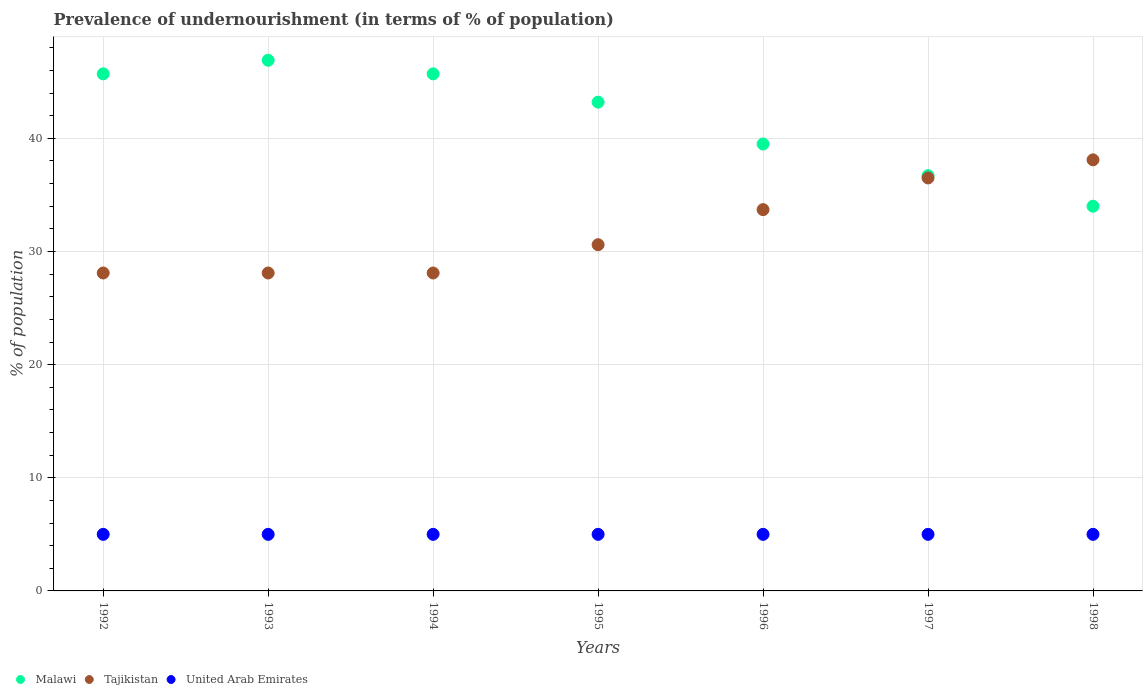How many different coloured dotlines are there?
Your answer should be very brief. 3. What is the percentage of undernourished population in United Arab Emirates in 1998?
Make the answer very short. 5. Across all years, what is the maximum percentage of undernourished population in Malawi?
Provide a short and direct response. 46.9. Across all years, what is the minimum percentage of undernourished population in Tajikistan?
Your response must be concise. 28.1. In which year was the percentage of undernourished population in United Arab Emirates minimum?
Your response must be concise. 1992. What is the total percentage of undernourished population in Malawi in the graph?
Provide a short and direct response. 291.7. What is the difference between the percentage of undernourished population in United Arab Emirates in 1993 and that in 1994?
Give a very brief answer. 0. What is the difference between the percentage of undernourished population in Tajikistan in 1998 and the percentage of undernourished population in United Arab Emirates in 1996?
Keep it short and to the point. 33.1. In the year 1996, what is the difference between the percentage of undernourished population in Malawi and percentage of undernourished population in Tajikistan?
Your answer should be compact. 5.8. What is the ratio of the percentage of undernourished population in Tajikistan in 1992 to that in 1997?
Ensure brevity in your answer.  0.77. Is the percentage of undernourished population in Tajikistan in 1994 less than that in 1996?
Keep it short and to the point. Yes. What is the difference between the highest and the second highest percentage of undernourished population in Malawi?
Your answer should be very brief. 1.2. What is the difference between the highest and the lowest percentage of undernourished population in Malawi?
Provide a succinct answer. 12.9. Is the percentage of undernourished population in United Arab Emirates strictly less than the percentage of undernourished population in Malawi over the years?
Provide a succinct answer. Yes. How many dotlines are there?
Your answer should be compact. 3. What is the title of the graph?
Give a very brief answer. Prevalence of undernourishment (in terms of % of population). What is the label or title of the X-axis?
Offer a terse response. Years. What is the label or title of the Y-axis?
Your answer should be very brief. % of population. What is the % of population in Malawi in 1992?
Your answer should be compact. 45.7. What is the % of population in Tajikistan in 1992?
Your answer should be compact. 28.1. What is the % of population in United Arab Emirates in 1992?
Ensure brevity in your answer.  5. What is the % of population in Malawi in 1993?
Your response must be concise. 46.9. What is the % of population in Tajikistan in 1993?
Offer a very short reply. 28.1. What is the % of population of Malawi in 1994?
Ensure brevity in your answer.  45.7. What is the % of population in Tajikistan in 1994?
Make the answer very short. 28.1. What is the % of population in Malawi in 1995?
Provide a succinct answer. 43.2. What is the % of population of Tajikistan in 1995?
Provide a short and direct response. 30.6. What is the % of population in Malawi in 1996?
Make the answer very short. 39.5. What is the % of population of Tajikistan in 1996?
Provide a succinct answer. 33.7. What is the % of population in United Arab Emirates in 1996?
Your answer should be very brief. 5. What is the % of population of Malawi in 1997?
Make the answer very short. 36.7. What is the % of population in Tajikistan in 1997?
Give a very brief answer. 36.5. What is the % of population in Malawi in 1998?
Keep it short and to the point. 34. What is the % of population of Tajikistan in 1998?
Your answer should be very brief. 38.1. Across all years, what is the maximum % of population of Malawi?
Make the answer very short. 46.9. Across all years, what is the maximum % of population in Tajikistan?
Give a very brief answer. 38.1. Across all years, what is the minimum % of population of Tajikistan?
Your response must be concise. 28.1. What is the total % of population of Malawi in the graph?
Your answer should be compact. 291.7. What is the total % of population of Tajikistan in the graph?
Give a very brief answer. 223.2. What is the total % of population of United Arab Emirates in the graph?
Keep it short and to the point. 35. What is the difference between the % of population of Tajikistan in 1992 and that in 1993?
Your response must be concise. 0. What is the difference between the % of population in Malawi in 1992 and that in 1994?
Offer a very short reply. 0. What is the difference between the % of population of United Arab Emirates in 1992 and that in 1994?
Offer a terse response. 0. What is the difference between the % of population in Tajikistan in 1992 and that in 1995?
Offer a very short reply. -2.5. What is the difference between the % of population in United Arab Emirates in 1992 and that in 1995?
Keep it short and to the point. 0. What is the difference between the % of population in Tajikistan in 1993 and that in 1994?
Provide a short and direct response. 0. What is the difference between the % of population of United Arab Emirates in 1993 and that in 1995?
Make the answer very short. 0. What is the difference between the % of population of United Arab Emirates in 1993 and that in 1996?
Provide a short and direct response. 0. What is the difference between the % of population of Malawi in 1993 and that in 1997?
Ensure brevity in your answer.  10.2. What is the difference between the % of population in Tajikistan in 1993 and that in 1997?
Your answer should be compact. -8.4. What is the difference between the % of population of United Arab Emirates in 1993 and that in 1997?
Your answer should be very brief. 0. What is the difference between the % of population in Malawi in 1993 and that in 1998?
Ensure brevity in your answer.  12.9. What is the difference between the % of population in Tajikistan in 1993 and that in 1998?
Provide a short and direct response. -10. What is the difference between the % of population in United Arab Emirates in 1993 and that in 1998?
Keep it short and to the point. 0. What is the difference between the % of population of Tajikistan in 1994 and that in 1995?
Offer a very short reply. -2.5. What is the difference between the % of population in Tajikistan in 1994 and that in 1997?
Make the answer very short. -8.4. What is the difference between the % of population of Malawi in 1994 and that in 1998?
Provide a short and direct response. 11.7. What is the difference between the % of population of Tajikistan in 1994 and that in 1998?
Offer a very short reply. -10. What is the difference between the % of population in United Arab Emirates in 1995 and that in 1996?
Offer a terse response. 0. What is the difference between the % of population in United Arab Emirates in 1995 and that in 1997?
Make the answer very short. 0. What is the difference between the % of population of Malawi in 1996 and that in 1997?
Make the answer very short. 2.8. What is the difference between the % of population of Tajikistan in 1996 and that in 1997?
Give a very brief answer. -2.8. What is the difference between the % of population in United Arab Emirates in 1996 and that in 1997?
Keep it short and to the point. 0. What is the difference between the % of population in Malawi in 1996 and that in 1998?
Keep it short and to the point. 5.5. What is the difference between the % of population in United Arab Emirates in 1996 and that in 1998?
Your answer should be very brief. 0. What is the difference between the % of population of Malawi in 1997 and that in 1998?
Give a very brief answer. 2.7. What is the difference between the % of population in Tajikistan in 1997 and that in 1998?
Provide a short and direct response. -1.6. What is the difference between the % of population in Malawi in 1992 and the % of population in United Arab Emirates in 1993?
Provide a short and direct response. 40.7. What is the difference between the % of population of Tajikistan in 1992 and the % of population of United Arab Emirates in 1993?
Your answer should be very brief. 23.1. What is the difference between the % of population in Malawi in 1992 and the % of population in United Arab Emirates in 1994?
Provide a succinct answer. 40.7. What is the difference between the % of population of Tajikistan in 1992 and the % of population of United Arab Emirates in 1994?
Give a very brief answer. 23.1. What is the difference between the % of population in Malawi in 1992 and the % of population in United Arab Emirates in 1995?
Your response must be concise. 40.7. What is the difference between the % of population in Tajikistan in 1992 and the % of population in United Arab Emirates in 1995?
Give a very brief answer. 23.1. What is the difference between the % of population in Malawi in 1992 and the % of population in United Arab Emirates in 1996?
Ensure brevity in your answer.  40.7. What is the difference between the % of population in Tajikistan in 1992 and the % of population in United Arab Emirates in 1996?
Offer a very short reply. 23.1. What is the difference between the % of population in Malawi in 1992 and the % of population in Tajikistan in 1997?
Offer a terse response. 9.2. What is the difference between the % of population of Malawi in 1992 and the % of population of United Arab Emirates in 1997?
Your answer should be very brief. 40.7. What is the difference between the % of population of Tajikistan in 1992 and the % of population of United Arab Emirates in 1997?
Give a very brief answer. 23.1. What is the difference between the % of population of Malawi in 1992 and the % of population of Tajikistan in 1998?
Provide a short and direct response. 7.6. What is the difference between the % of population in Malawi in 1992 and the % of population in United Arab Emirates in 1998?
Offer a terse response. 40.7. What is the difference between the % of population in Tajikistan in 1992 and the % of population in United Arab Emirates in 1998?
Provide a succinct answer. 23.1. What is the difference between the % of population in Malawi in 1993 and the % of population in Tajikistan in 1994?
Your response must be concise. 18.8. What is the difference between the % of population in Malawi in 1993 and the % of population in United Arab Emirates in 1994?
Provide a short and direct response. 41.9. What is the difference between the % of population of Tajikistan in 1993 and the % of population of United Arab Emirates in 1994?
Provide a succinct answer. 23.1. What is the difference between the % of population in Malawi in 1993 and the % of population in Tajikistan in 1995?
Ensure brevity in your answer.  16.3. What is the difference between the % of population in Malawi in 1993 and the % of population in United Arab Emirates in 1995?
Offer a terse response. 41.9. What is the difference between the % of population in Tajikistan in 1993 and the % of population in United Arab Emirates in 1995?
Your answer should be compact. 23.1. What is the difference between the % of population in Malawi in 1993 and the % of population in United Arab Emirates in 1996?
Your answer should be very brief. 41.9. What is the difference between the % of population in Tajikistan in 1993 and the % of population in United Arab Emirates in 1996?
Provide a short and direct response. 23.1. What is the difference between the % of population in Malawi in 1993 and the % of population in Tajikistan in 1997?
Ensure brevity in your answer.  10.4. What is the difference between the % of population of Malawi in 1993 and the % of population of United Arab Emirates in 1997?
Ensure brevity in your answer.  41.9. What is the difference between the % of population of Tajikistan in 1993 and the % of population of United Arab Emirates in 1997?
Provide a succinct answer. 23.1. What is the difference between the % of population of Malawi in 1993 and the % of population of Tajikistan in 1998?
Ensure brevity in your answer.  8.8. What is the difference between the % of population in Malawi in 1993 and the % of population in United Arab Emirates in 1998?
Make the answer very short. 41.9. What is the difference between the % of population in Tajikistan in 1993 and the % of population in United Arab Emirates in 1998?
Make the answer very short. 23.1. What is the difference between the % of population of Malawi in 1994 and the % of population of United Arab Emirates in 1995?
Keep it short and to the point. 40.7. What is the difference between the % of population in Tajikistan in 1994 and the % of population in United Arab Emirates in 1995?
Offer a terse response. 23.1. What is the difference between the % of population of Malawi in 1994 and the % of population of United Arab Emirates in 1996?
Ensure brevity in your answer.  40.7. What is the difference between the % of population in Tajikistan in 1994 and the % of population in United Arab Emirates in 1996?
Offer a terse response. 23.1. What is the difference between the % of population in Malawi in 1994 and the % of population in Tajikistan in 1997?
Provide a short and direct response. 9.2. What is the difference between the % of population of Malawi in 1994 and the % of population of United Arab Emirates in 1997?
Keep it short and to the point. 40.7. What is the difference between the % of population of Tajikistan in 1994 and the % of population of United Arab Emirates in 1997?
Your answer should be very brief. 23.1. What is the difference between the % of population in Malawi in 1994 and the % of population in United Arab Emirates in 1998?
Give a very brief answer. 40.7. What is the difference between the % of population in Tajikistan in 1994 and the % of population in United Arab Emirates in 1998?
Your answer should be very brief. 23.1. What is the difference between the % of population of Malawi in 1995 and the % of population of United Arab Emirates in 1996?
Provide a succinct answer. 38.2. What is the difference between the % of population of Tajikistan in 1995 and the % of population of United Arab Emirates in 1996?
Your response must be concise. 25.6. What is the difference between the % of population in Malawi in 1995 and the % of population in Tajikistan in 1997?
Your answer should be compact. 6.7. What is the difference between the % of population of Malawi in 1995 and the % of population of United Arab Emirates in 1997?
Ensure brevity in your answer.  38.2. What is the difference between the % of population of Tajikistan in 1995 and the % of population of United Arab Emirates in 1997?
Your answer should be very brief. 25.6. What is the difference between the % of population in Malawi in 1995 and the % of population in United Arab Emirates in 1998?
Keep it short and to the point. 38.2. What is the difference between the % of population in Tajikistan in 1995 and the % of population in United Arab Emirates in 1998?
Provide a short and direct response. 25.6. What is the difference between the % of population in Malawi in 1996 and the % of population in Tajikistan in 1997?
Give a very brief answer. 3. What is the difference between the % of population in Malawi in 1996 and the % of population in United Arab Emirates in 1997?
Provide a succinct answer. 34.5. What is the difference between the % of population of Tajikistan in 1996 and the % of population of United Arab Emirates in 1997?
Offer a terse response. 28.7. What is the difference between the % of population in Malawi in 1996 and the % of population in Tajikistan in 1998?
Your answer should be very brief. 1.4. What is the difference between the % of population of Malawi in 1996 and the % of population of United Arab Emirates in 1998?
Your response must be concise. 34.5. What is the difference between the % of population of Tajikistan in 1996 and the % of population of United Arab Emirates in 1998?
Offer a terse response. 28.7. What is the difference between the % of population in Malawi in 1997 and the % of population in Tajikistan in 1998?
Ensure brevity in your answer.  -1.4. What is the difference between the % of population in Malawi in 1997 and the % of population in United Arab Emirates in 1998?
Give a very brief answer. 31.7. What is the difference between the % of population in Tajikistan in 1997 and the % of population in United Arab Emirates in 1998?
Keep it short and to the point. 31.5. What is the average % of population in Malawi per year?
Offer a terse response. 41.67. What is the average % of population in Tajikistan per year?
Provide a short and direct response. 31.89. What is the average % of population of United Arab Emirates per year?
Ensure brevity in your answer.  5. In the year 1992, what is the difference between the % of population in Malawi and % of population in United Arab Emirates?
Your answer should be compact. 40.7. In the year 1992, what is the difference between the % of population in Tajikistan and % of population in United Arab Emirates?
Make the answer very short. 23.1. In the year 1993, what is the difference between the % of population of Malawi and % of population of Tajikistan?
Offer a terse response. 18.8. In the year 1993, what is the difference between the % of population in Malawi and % of population in United Arab Emirates?
Your answer should be compact. 41.9. In the year 1993, what is the difference between the % of population of Tajikistan and % of population of United Arab Emirates?
Offer a terse response. 23.1. In the year 1994, what is the difference between the % of population in Malawi and % of population in Tajikistan?
Make the answer very short. 17.6. In the year 1994, what is the difference between the % of population of Malawi and % of population of United Arab Emirates?
Offer a terse response. 40.7. In the year 1994, what is the difference between the % of population in Tajikistan and % of population in United Arab Emirates?
Ensure brevity in your answer.  23.1. In the year 1995, what is the difference between the % of population in Malawi and % of population in Tajikistan?
Your answer should be compact. 12.6. In the year 1995, what is the difference between the % of population of Malawi and % of population of United Arab Emirates?
Provide a succinct answer. 38.2. In the year 1995, what is the difference between the % of population in Tajikistan and % of population in United Arab Emirates?
Keep it short and to the point. 25.6. In the year 1996, what is the difference between the % of population in Malawi and % of population in United Arab Emirates?
Keep it short and to the point. 34.5. In the year 1996, what is the difference between the % of population in Tajikistan and % of population in United Arab Emirates?
Provide a short and direct response. 28.7. In the year 1997, what is the difference between the % of population of Malawi and % of population of United Arab Emirates?
Keep it short and to the point. 31.7. In the year 1997, what is the difference between the % of population in Tajikistan and % of population in United Arab Emirates?
Offer a very short reply. 31.5. In the year 1998, what is the difference between the % of population of Malawi and % of population of United Arab Emirates?
Offer a very short reply. 29. In the year 1998, what is the difference between the % of population of Tajikistan and % of population of United Arab Emirates?
Keep it short and to the point. 33.1. What is the ratio of the % of population of Malawi in 1992 to that in 1993?
Offer a terse response. 0.97. What is the ratio of the % of population of Malawi in 1992 to that in 1994?
Your answer should be compact. 1. What is the ratio of the % of population in United Arab Emirates in 1992 to that in 1994?
Offer a terse response. 1. What is the ratio of the % of population in Malawi in 1992 to that in 1995?
Your answer should be very brief. 1.06. What is the ratio of the % of population in Tajikistan in 1992 to that in 1995?
Your answer should be very brief. 0.92. What is the ratio of the % of population in United Arab Emirates in 1992 to that in 1995?
Provide a short and direct response. 1. What is the ratio of the % of population in Malawi in 1992 to that in 1996?
Your response must be concise. 1.16. What is the ratio of the % of population of Tajikistan in 1992 to that in 1996?
Your response must be concise. 0.83. What is the ratio of the % of population of Malawi in 1992 to that in 1997?
Provide a short and direct response. 1.25. What is the ratio of the % of population of Tajikistan in 1992 to that in 1997?
Your answer should be compact. 0.77. What is the ratio of the % of population of United Arab Emirates in 1992 to that in 1997?
Your answer should be compact. 1. What is the ratio of the % of population of Malawi in 1992 to that in 1998?
Your answer should be very brief. 1.34. What is the ratio of the % of population of Tajikistan in 1992 to that in 1998?
Your answer should be compact. 0.74. What is the ratio of the % of population of Malawi in 1993 to that in 1994?
Your answer should be compact. 1.03. What is the ratio of the % of population in Tajikistan in 1993 to that in 1994?
Give a very brief answer. 1. What is the ratio of the % of population of Malawi in 1993 to that in 1995?
Provide a succinct answer. 1.09. What is the ratio of the % of population in Tajikistan in 1993 to that in 1995?
Your answer should be compact. 0.92. What is the ratio of the % of population of Malawi in 1993 to that in 1996?
Provide a succinct answer. 1.19. What is the ratio of the % of population in Tajikistan in 1993 to that in 1996?
Your response must be concise. 0.83. What is the ratio of the % of population of United Arab Emirates in 1993 to that in 1996?
Make the answer very short. 1. What is the ratio of the % of population of Malawi in 1993 to that in 1997?
Provide a short and direct response. 1.28. What is the ratio of the % of population in Tajikistan in 1993 to that in 1997?
Ensure brevity in your answer.  0.77. What is the ratio of the % of population in United Arab Emirates in 1993 to that in 1997?
Your answer should be very brief. 1. What is the ratio of the % of population in Malawi in 1993 to that in 1998?
Offer a terse response. 1.38. What is the ratio of the % of population in Tajikistan in 1993 to that in 1998?
Make the answer very short. 0.74. What is the ratio of the % of population in Malawi in 1994 to that in 1995?
Your response must be concise. 1.06. What is the ratio of the % of population in Tajikistan in 1994 to that in 1995?
Keep it short and to the point. 0.92. What is the ratio of the % of population in Malawi in 1994 to that in 1996?
Make the answer very short. 1.16. What is the ratio of the % of population of Tajikistan in 1994 to that in 1996?
Provide a short and direct response. 0.83. What is the ratio of the % of population in Malawi in 1994 to that in 1997?
Your answer should be very brief. 1.25. What is the ratio of the % of population of Tajikistan in 1994 to that in 1997?
Your answer should be very brief. 0.77. What is the ratio of the % of population of Malawi in 1994 to that in 1998?
Provide a succinct answer. 1.34. What is the ratio of the % of population of Tajikistan in 1994 to that in 1998?
Make the answer very short. 0.74. What is the ratio of the % of population of United Arab Emirates in 1994 to that in 1998?
Give a very brief answer. 1. What is the ratio of the % of population of Malawi in 1995 to that in 1996?
Make the answer very short. 1.09. What is the ratio of the % of population of Tajikistan in 1995 to that in 1996?
Your answer should be compact. 0.91. What is the ratio of the % of population in United Arab Emirates in 1995 to that in 1996?
Your response must be concise. 1. What is the ratio of the % of population of Malawi in 1995 to that in 1997?
Offer a terse response. 1.18. What is the ratio of the % of population in Tajikistan in 1995 to that in 1997?
Provide a short and direct response. 0.84. What is the ratio of the % of population of Malawi in 1995 to that in 1998?
Your response must be concise. 1.27. What is the ratio of the % of population of Tajikistan in 1995 to that in 1998?
Provide a succinct answer. 0.8. What is the ratio of the % of population of Malawi in 1996 to that in 1997?
Your response must be concise. 1.08. What is the ratio of the % of population in Tajikistan in 1996 to that in 1997?
Give a very brief answer. 0.92. What is the ratio of the % of population of Malawi in 1996 to that in 1998?
Ensure brevity in your answer.  1.16. What is the ratio of the % of population of Tajikistan in 1996 to that in 1998?
Offer a terse response. 0.88. What is the ratio of the % of population in Malawi in 1997 to that in 1998?
Offer a very short reply. 1.08. What is the ratio of the % of population in Tajikistan in 1997 to that in 1998?
Provide a succinct answer. 0.96. What is the difference between the highest and the second highest % of population of Malawi?
Provide a short and direct response. 1.2. What is the difference between the highest and the second highest % of population of Tajikistan?
Offer a terse response. 1.6. What is the difference between the highest and the second highest % of population of United Arab Emirates?
Make the answer very short. 0. What is the difference between the highest and the lowest % of population of Malawi?
Offer a terse response. 12.9. What is the difference between the highest and the lowest % of population in United Arab Emirates?
Provide a succinct answer. 0. 